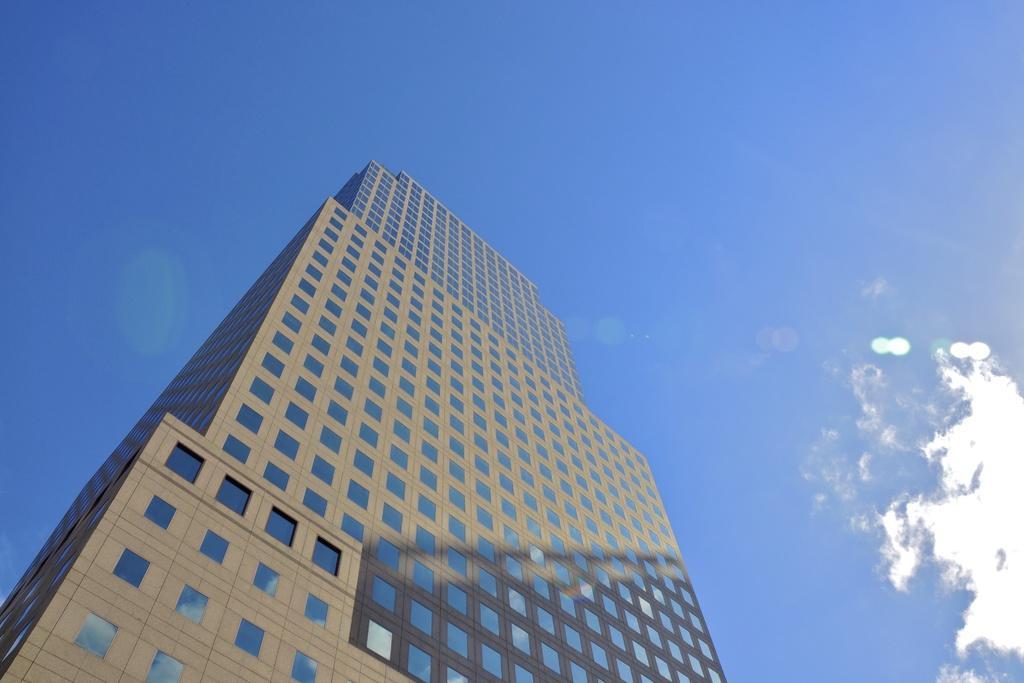In one or two sentences, can you explain what this image depicts? In the center of the image, we can see a building and at the top, there are clouds in the sky. 